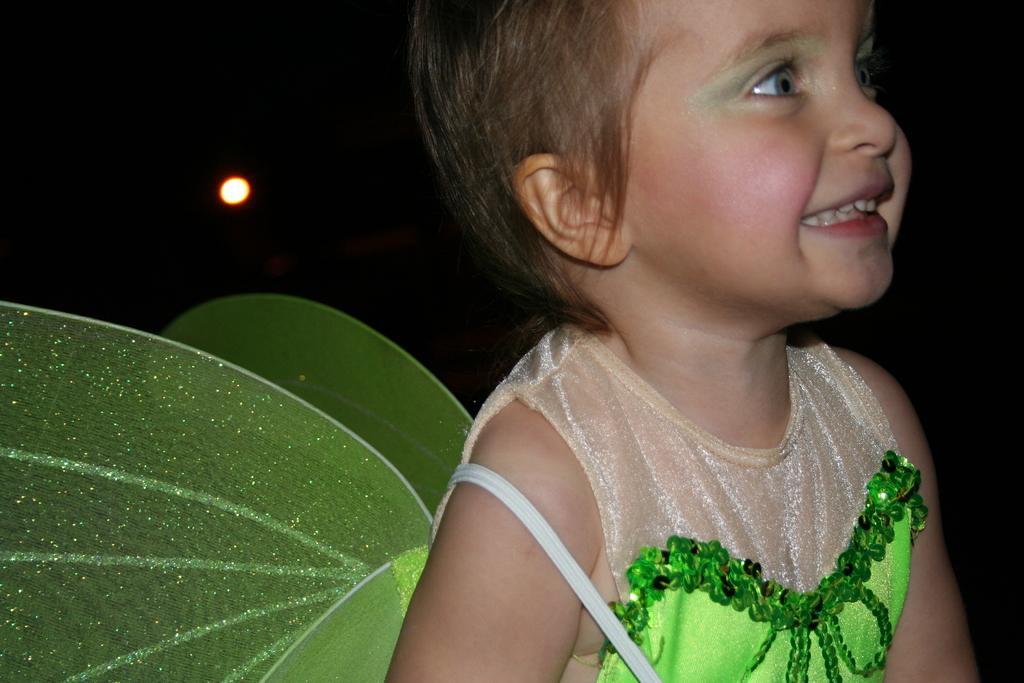Can you describe this image briefly? In this image I see a child who is wearing cream and green color dress and I see that the child is smiling and it is dark in the background and I see the light over here. 